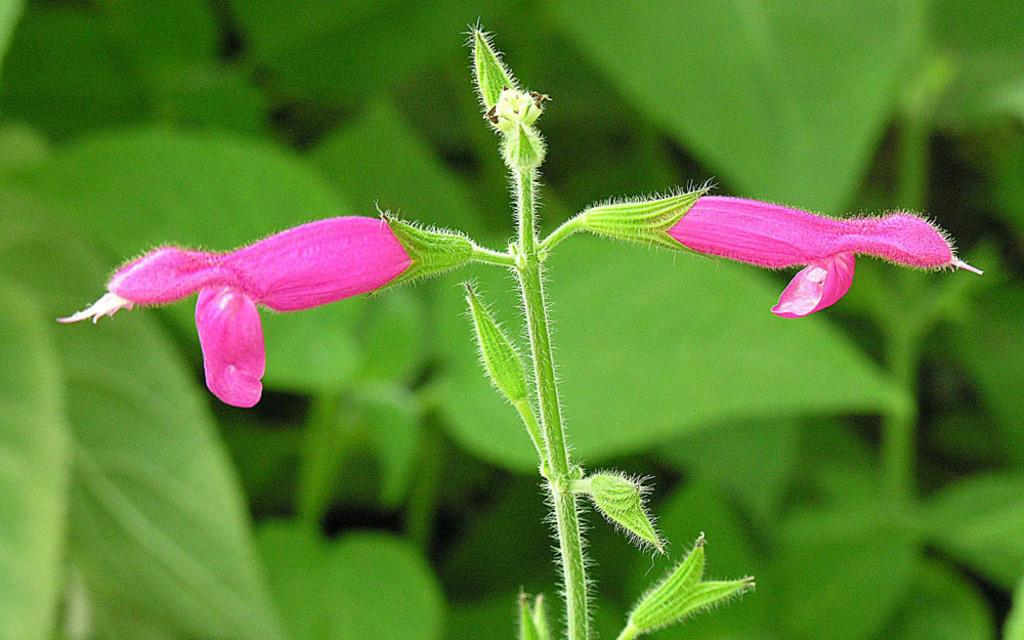What can be seen in the foreground of the picture? There are flowers, buds, and a stem of a plant in the foreground of the picture. What type of plant is depicted in the foreground? The stem of a plant in the foreground suggests that it is a flowering plant. What is visible in the background of the picture? There is greenery in the background of the picture. How is the background of the picture depicted? The background is blurred. Where is the deer located in the picture? There is no deer present in the picture. What type of pickle is featured in the foreground of the picture? There are no pickles present in the picture; it features flowers, buds, and a stem of a plant. 